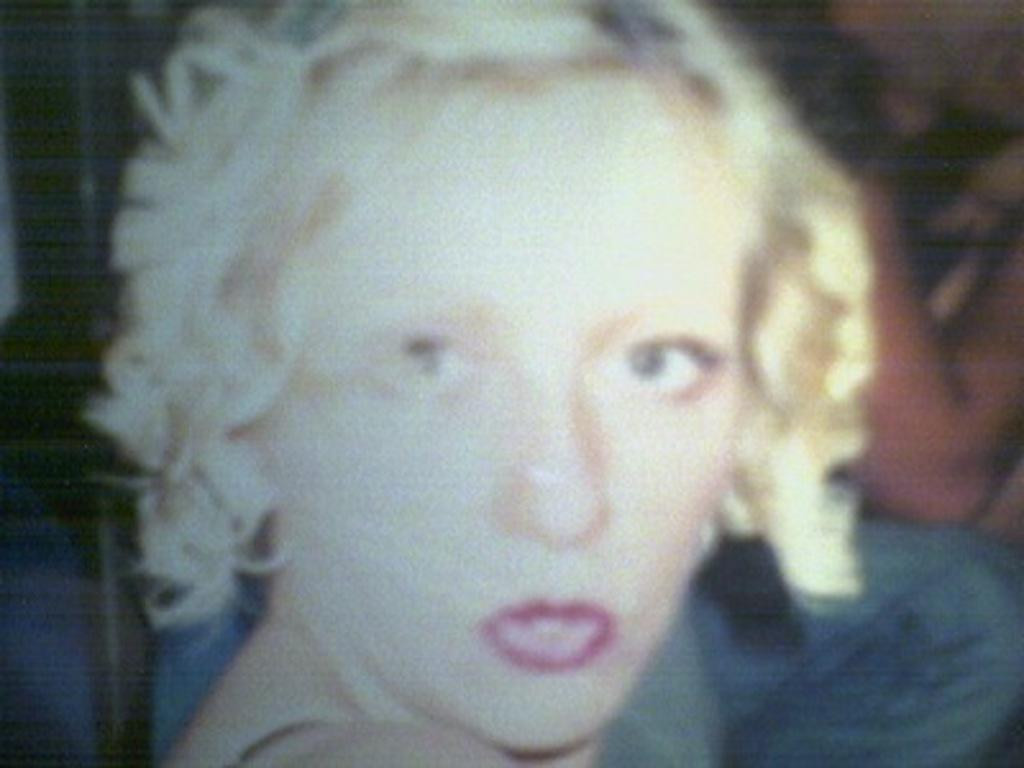Who is present in the image? There is a woman in the image. Can you describe the background of the image? There are some objects in the background of the image. What type of tub is visible in the image? There is no tub present in the image. How many clovers can be seen in the image? There are no clovers visible in the image. 